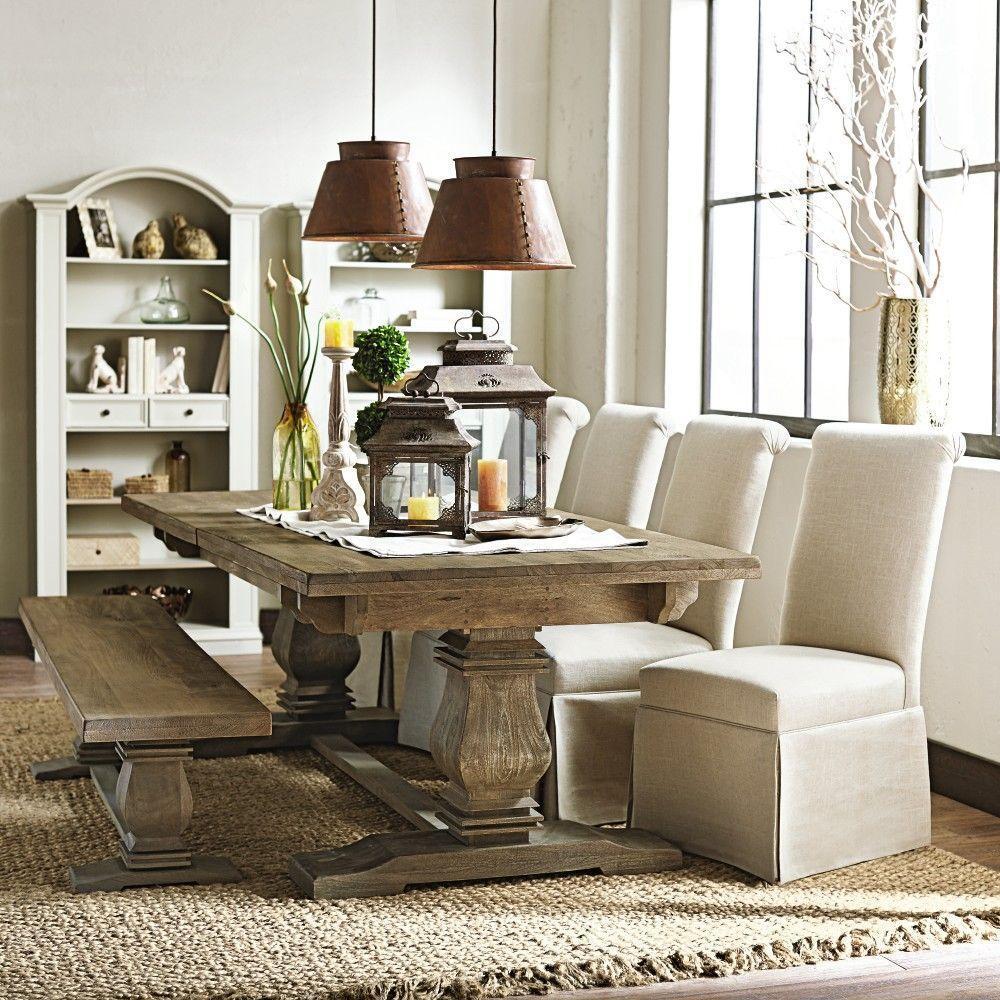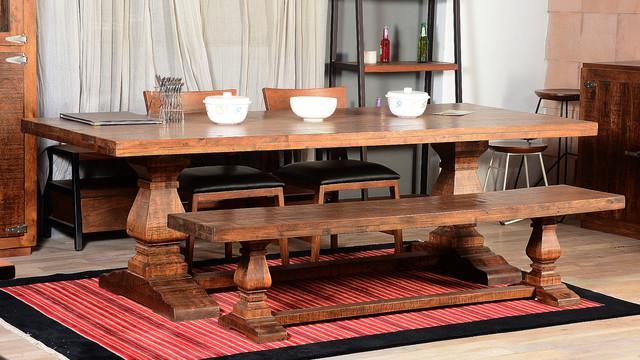The first image is the image on the left, the second image is the image on the right. Assess this claim about the two images: "A plant is sitting on the table in the image on the left.". Correct or not? Answer yes or no. Yes. The first image is the image on the left, the second image is the image on the right. For the images shown, is this caption "An image shows a pedestal table flanked by a long bench on one side and pale neutral fabric-covered chairs on the other side." true? Answer yes or no. Yes. 